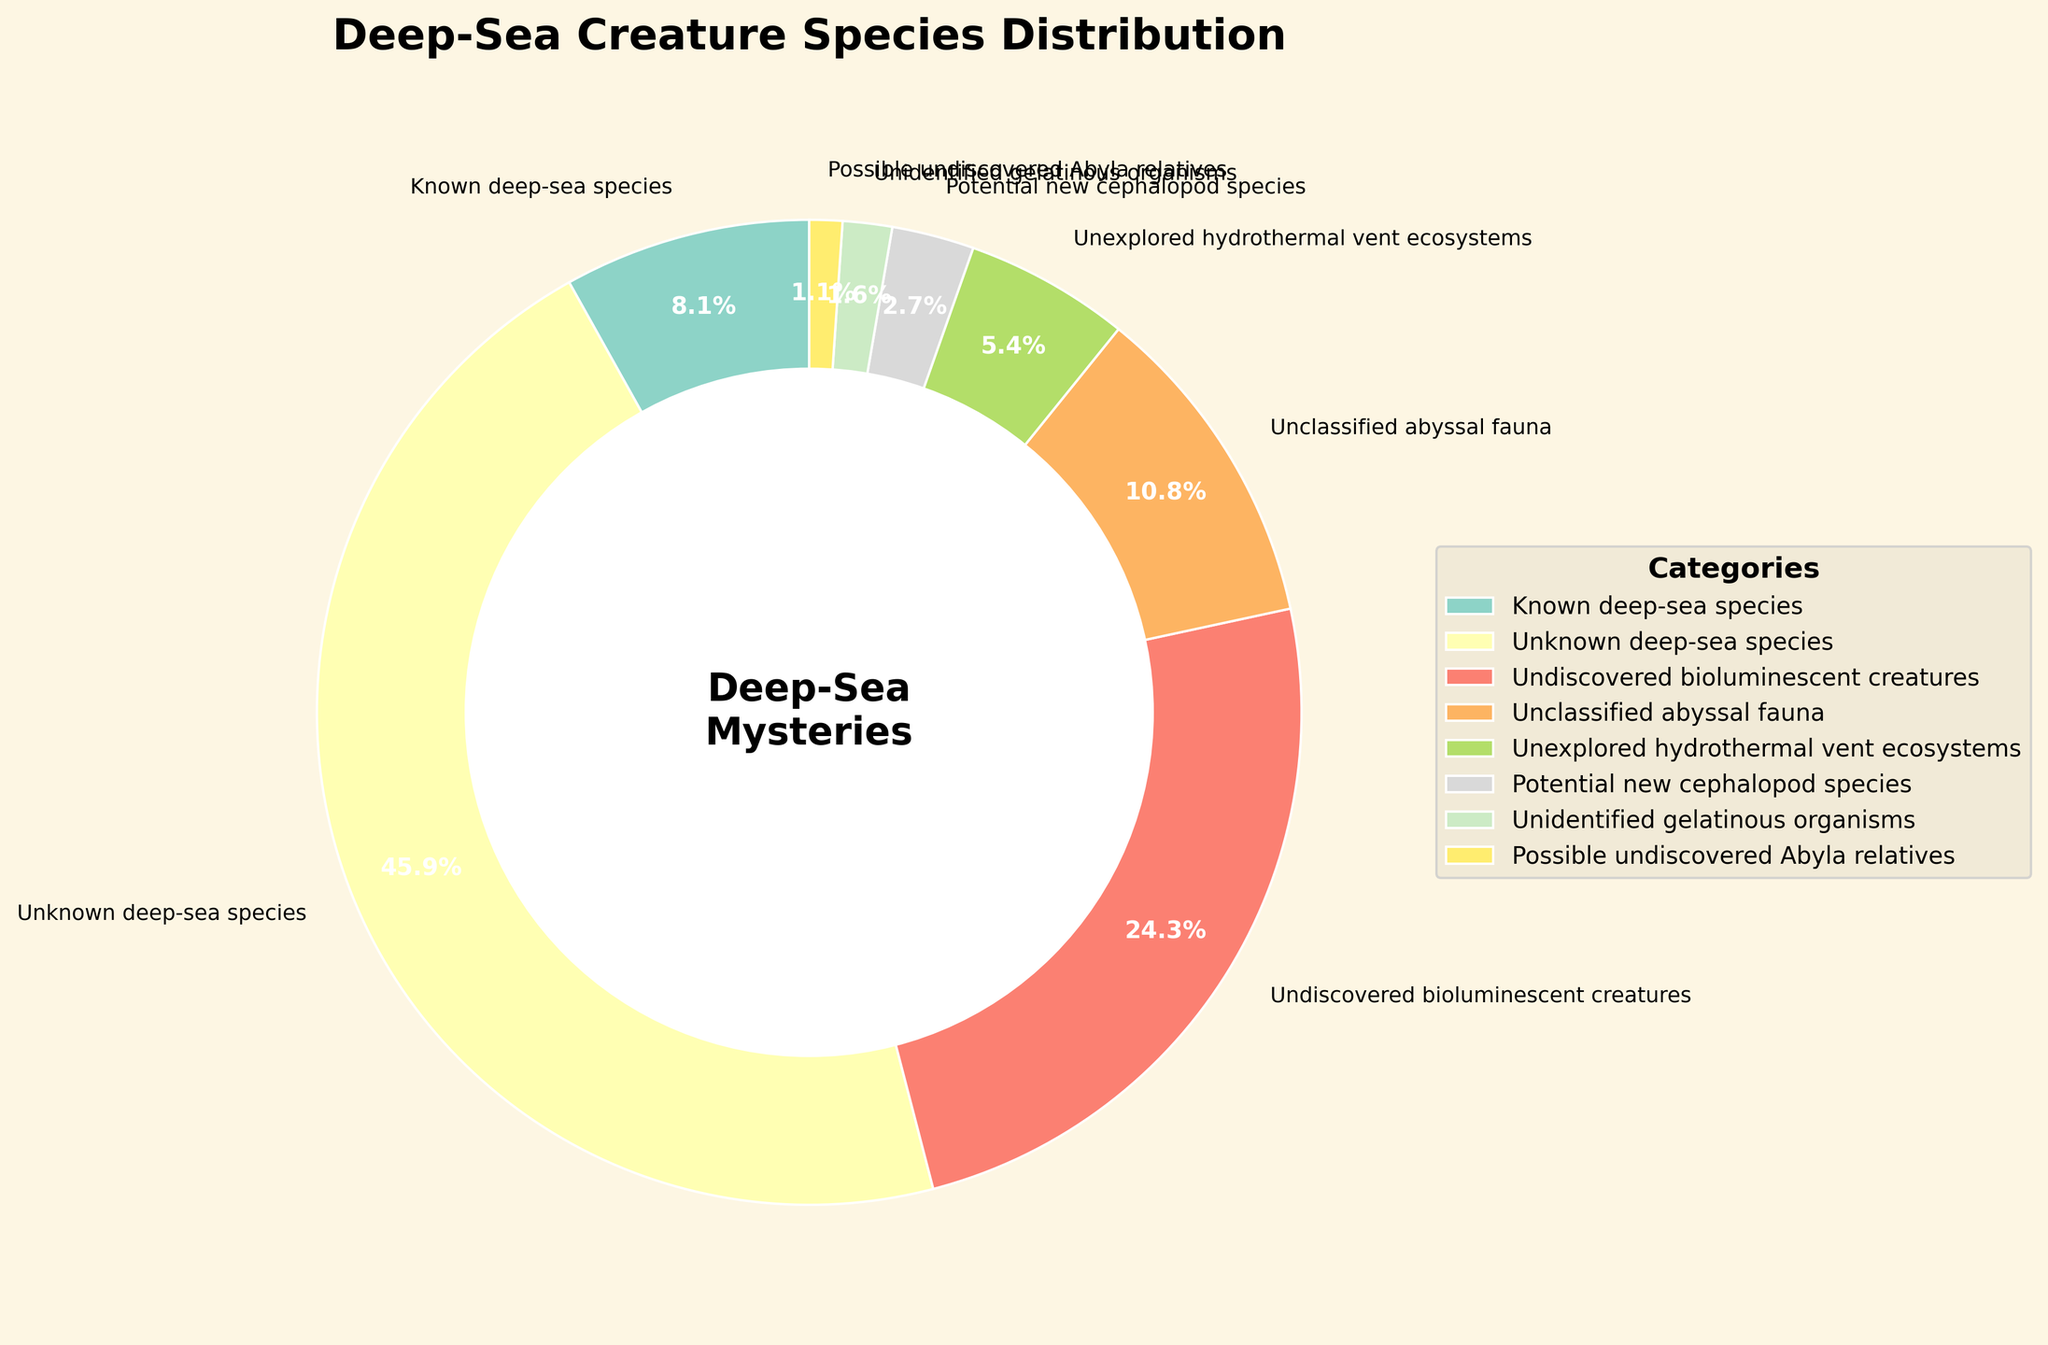What percentage of the deep-sea creatures are known species? The category "Known deep-sea species" shows a percentage of 15% on the pie chart.
Answer: 15% Are there more undiscovered bioluminescent creatures or unidentified gelatinous organisms? The pie chart shows 45% for "Undiscovered bioluminescent creatures" and 3% for "Unidentified gelatinous organisms". 45% is greater than 3%.
Answer: Undiscovered bioluminescent creatures Which category has the smallest percentage? The pie chart shows that "Possible undiscovered Abyla relatives" has the smallest slice with 2%.
Answer: Possible undiscovered Abyla relatives Combined, what percentage do the unexplored hydrothermal vent ecosystems and potential new cephalopod species account for? Adding the percentages of "Unexplored hydrothermal vent ecosystems" (10%) and "Potential new cephalopod species" (5%) gives 10% + 5% = 15%.
Answer: 15% How much larger is the percentage of unknown deep-sea species compared to known deep-sea species? The percentage of "Unknown deep-sea species" is 85%, and "Known deep-sea species" is 15%. Subtracting these gives 85% - 15% = 70%.
Answer: 70% What percentage of the categories are labeled as unknown, undiscovered, or unidentified? Adding percentages from categories labeled unknown, undiscovered, or unidentified: Unknown deep-sea species (85%), Undiscovered bioluminescent creatures (45%), Unclassified abyssal fauna (20%), Unexplored hydrothermal vent ecosystems (10%), Potential new cephalopod species (5%), Unidentified gelatinous organisms (3%), Possible undiscovered Abyla relatives (2%) = 85% + 45% + 20% + 10% + 5% + 3% + 2% = 170%.
Answer: 170% Which category occupies the largest portion of the pie chart? The pie chart indicates that "Unknown deep-sea species" has the largest portion with 85%.
Answer: Unknown deep-sea species Among unclassified abyssal fauna, unexplored hydrothermal vent ecosystems, and potential new cephalopod species, which has the highest percentage? The pie chart shows that "Unclassified abyssal fauna" (20%) has the highest percentage compared to "Unexplored hydrothermal vent ecosystems" (10%) and "Potential new cephalopod species" (5%).
Answer: Unclassified abyssal fauna 